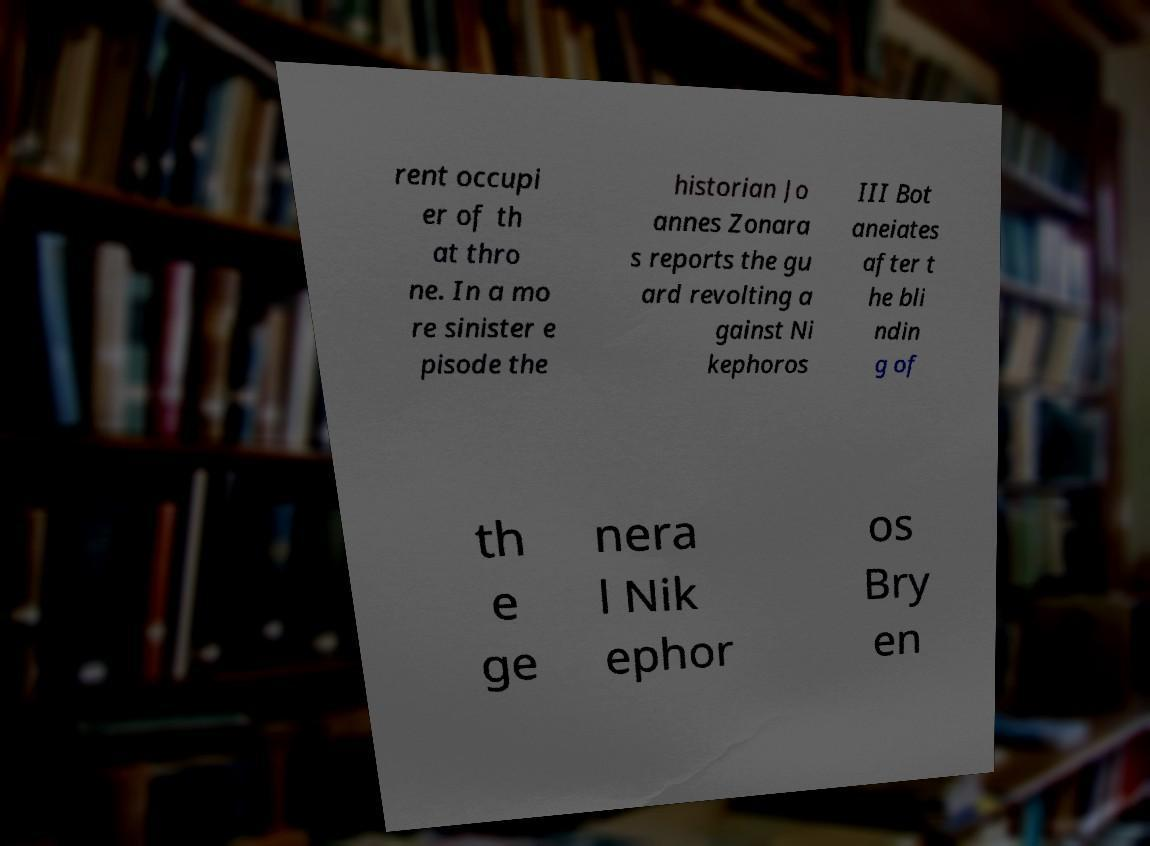I need the written content from this picture converted into text. Can you do that? rent occupi er of th at thro ne. In a mo re sinister e pisode the historian Jo annes Zonara s reports the gu ard revolting a gainst Ni kephoros III Bot aneiates after t he bli ndin g of th e ge nera l Nik ephor os Bry en 